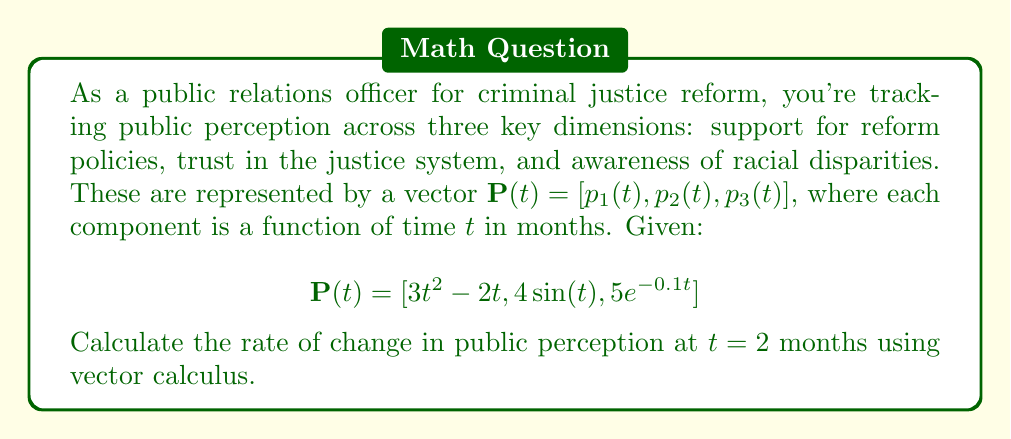Can you solve this math problem? To find the rate of change in public perception, we need to calculate the derivative of the vector $\mathbf{P}(t)$ with respect to time and then evaluate it at $t = 2$.

1) First, let's find $\frac{d\mathbf{P}}{dt}$ by differentiating each component:

   $\frac{d}{dt}(3t^2 - 2t) = 6t - 2$
   $\frac{d}{dt}(4\sin(t)) = 4\cos(t)$
   $\frac{d}{dt}(5e^{-0.1t}) = -0.5e^{-0.1t}$

2) So, $\frac{d\mathbf{P}}{dt} = [6t - 2, 4\cos(t), -0.5e^{-0.1t}]$

3) Now, we evaluate this at $t = 2$:

   $\frac{d\mathbf{P}}{dt}(2) = [6(2) - 2, 4\cos(2), -0.5e^{-0.1(2)}]$

4) Simplify:
   $= [10, 4\cos(2), -0.5e^{-0.2}]$

5) Calculate the remaining values:
   $\cos(2) \approx -0.4161$ (rounded to 4 decimal places)
   $e^{-0.2} \approx 0.8187$ (rounded to 4 decimal places)

6) Substituting these values:
   $\frac{d\mathbf{P}}{dt}(2) \approx [10, -1.6644, -0.4094]$

This vector represents the instantaneous rate of change in public perception across the three dimensions at $t = 2$ months.
Answer: $[10, -1.6644, -0.4094]$ 